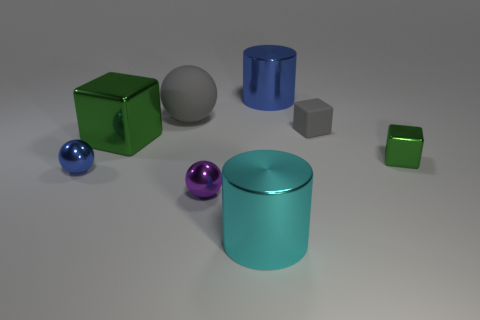Add 1 gray balls. How many objects exist? 9 Subtract all red cubes. Subtract all purple cylinders. How many cubes are left? 3 Subtract all blocks. How many objects are left? 5 Add 2 cyan metal objects. How many cyan metal objects exist? 3 Subtract 0 yellow cylinders. How many objects are left? 8 Subtract all blue rubber spheres. Subtract all big cylinders. How many objects are left? 6 Add 5 large balls. How many large balls are left? 6 